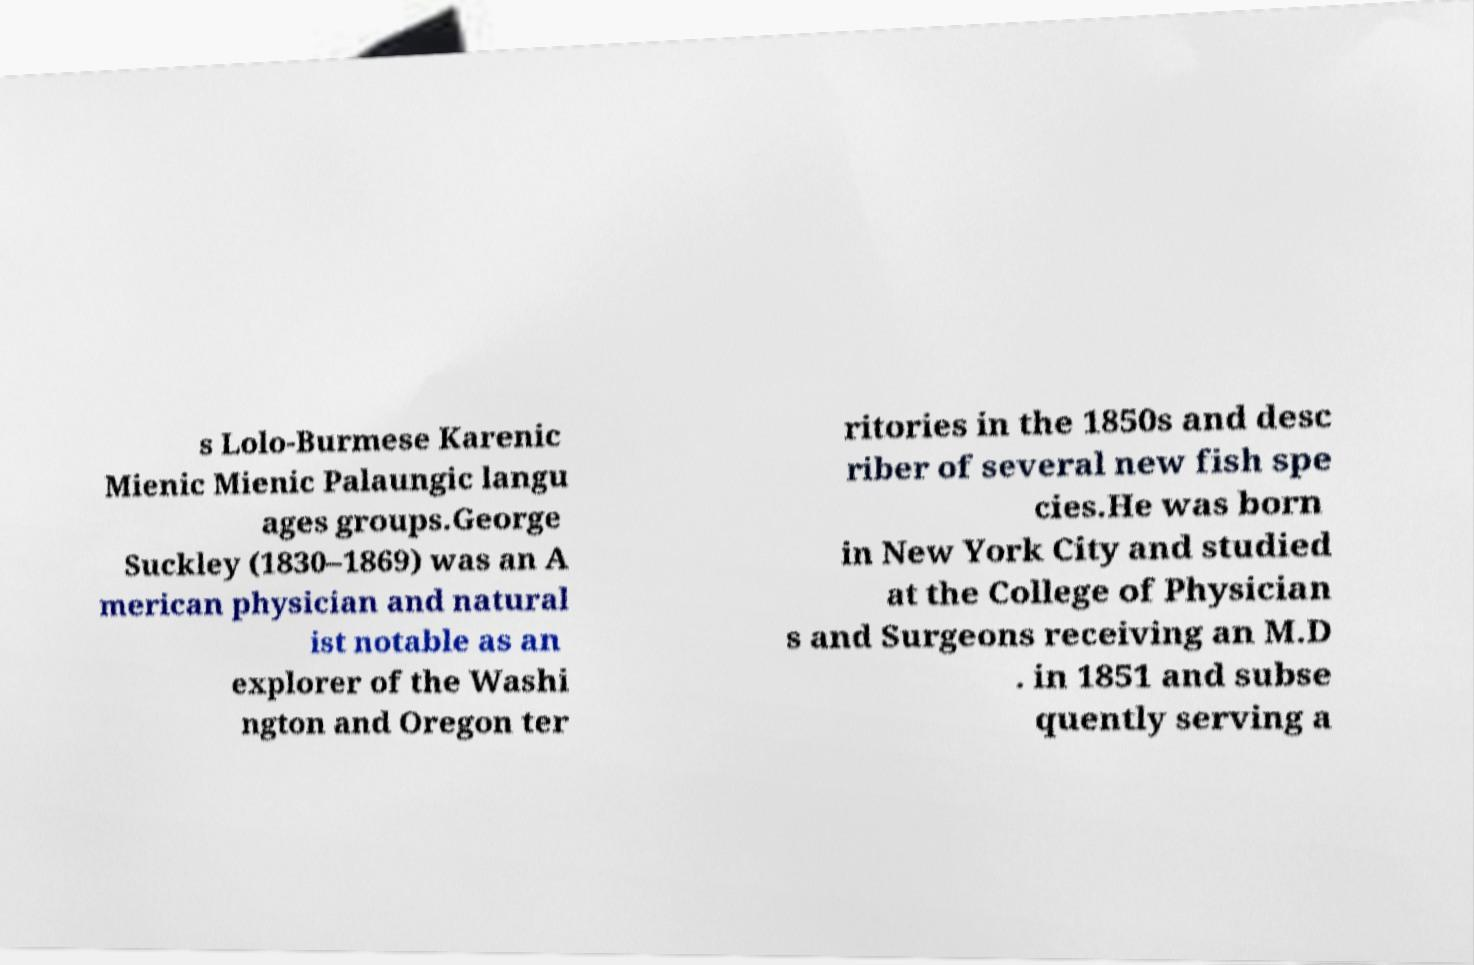I need the written content from this picture converted into text. Can you do that? s Lolo-Burmese Karenic Mienic Mienic Palaungic langu ages groups.George Suckley (1830–1869) was an A merican physician and natural ist notable as an explorer of the Washi ngton and Oregon ter ritories in the 1850s and desc riber of several new fish spe cies.He was born in New York City and studied at the College of Physician s and Surgeons receiving an M.D . in 1851 and subse quently serving a 